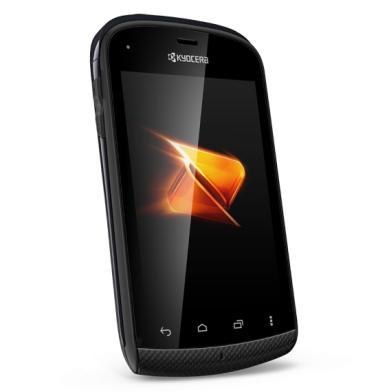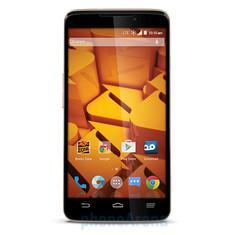The first image is the image on the left, the second image is the image on the right. Examine the images to the left and right. Is the description "All of the phones are flip-phones; they can be physically unfolded to open them." accurate? Answer yes or no. No. The first image is the image on the left, the second image is the image on the right. Examine the images to the left and right. Is the description "Every phone is a flip phone." accurate? Answer yes or no. No. 